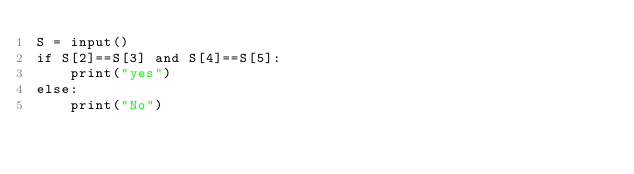Convert code to text. <code><loc_0><loc_0><loc_500><loc_500><_Python_>S = input()
if S[2]==S[3] and S[4]==S[5]:
    print("yes")
else:
    print("No")</code> 